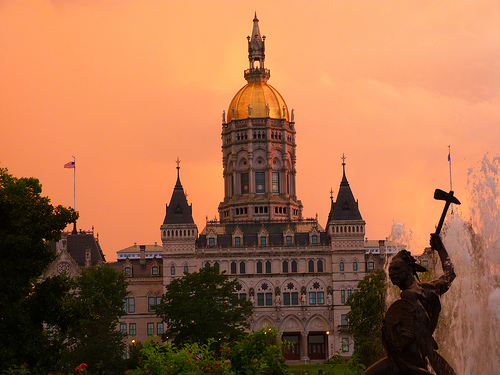<image>
Is there a building in front of the tree? Yes. The building is positioned in front of the tree, appearing closer to the camera viewpoint. Where is the palace in relation to the tree? Is it in front of the tree? No. The palace is not in front of the tree. The spatial positioning shows a different relationship between these objects. 